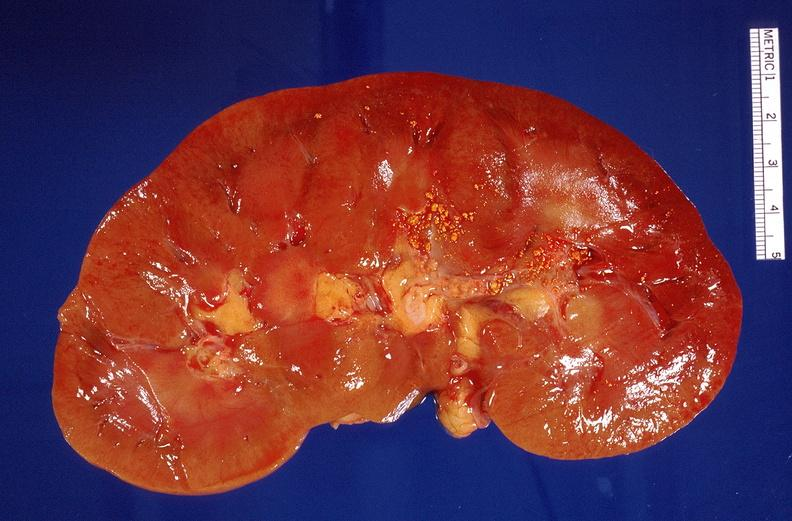does infarction secondary to shock show nephrolithiasis?
Answer the question using a single word or phrase. No 